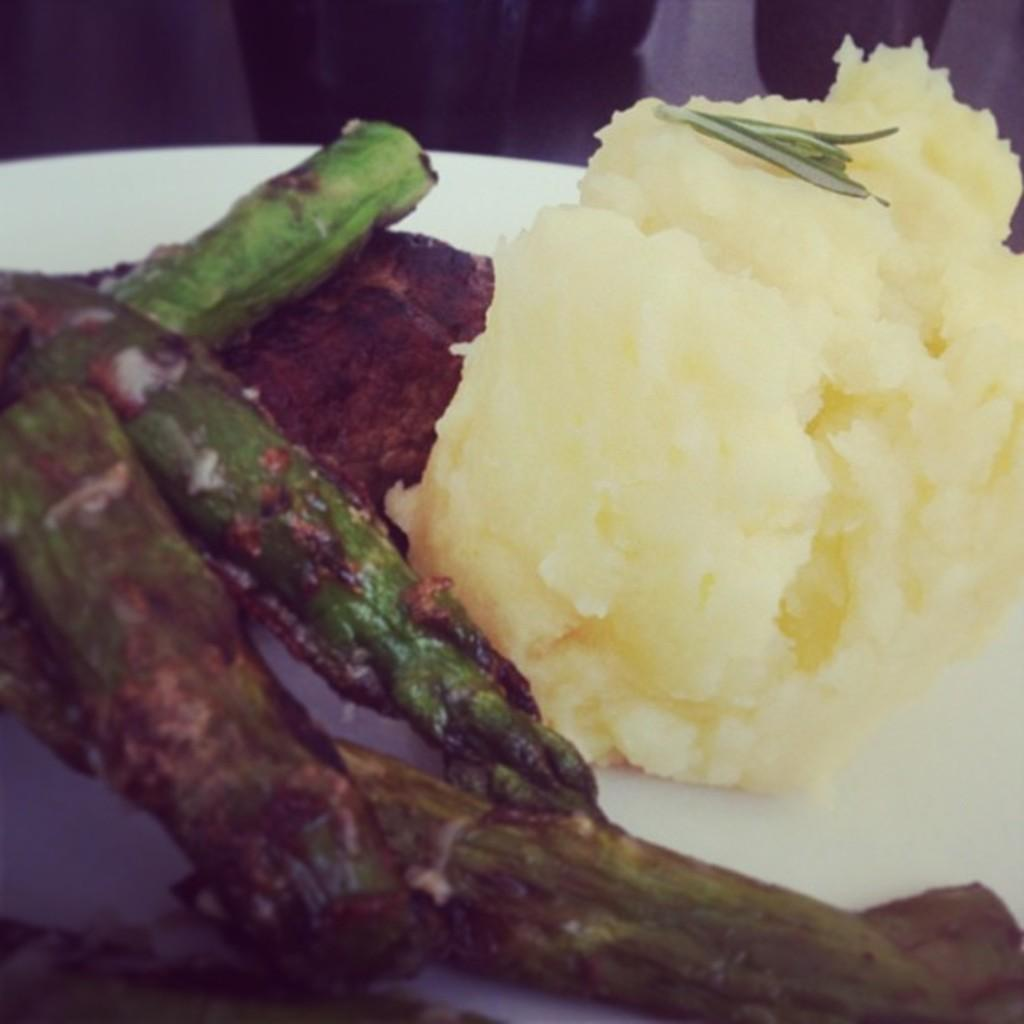What can be seen in the image? There are food items in the image. What is the color of the plate on which the food items are placed? The plate is white in color. How many times does the person in the image sneeze while eating the food? There is no person present in the image, so it is impossible to determine how many times they sneeze while eating the food. 